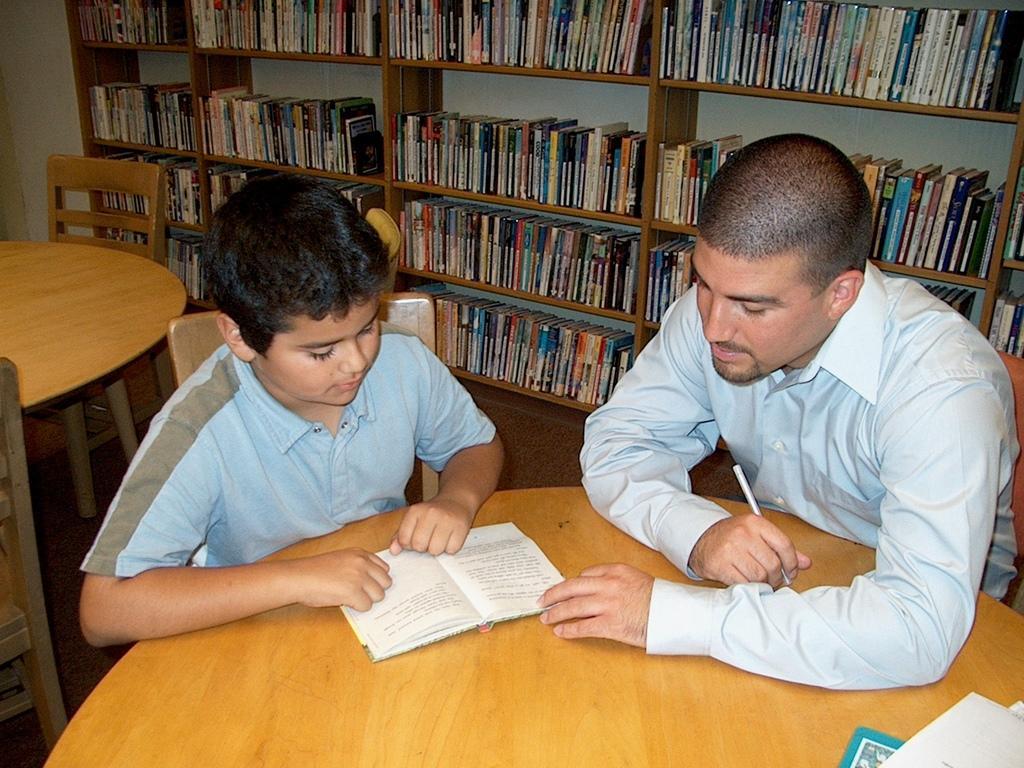Please provide a concise description of this image. This is the picture taken in a room, there are two person are sitting on a chair in front of the people there is a table on the table there are book and paper. Background of the people is a shelf with books and wall. 